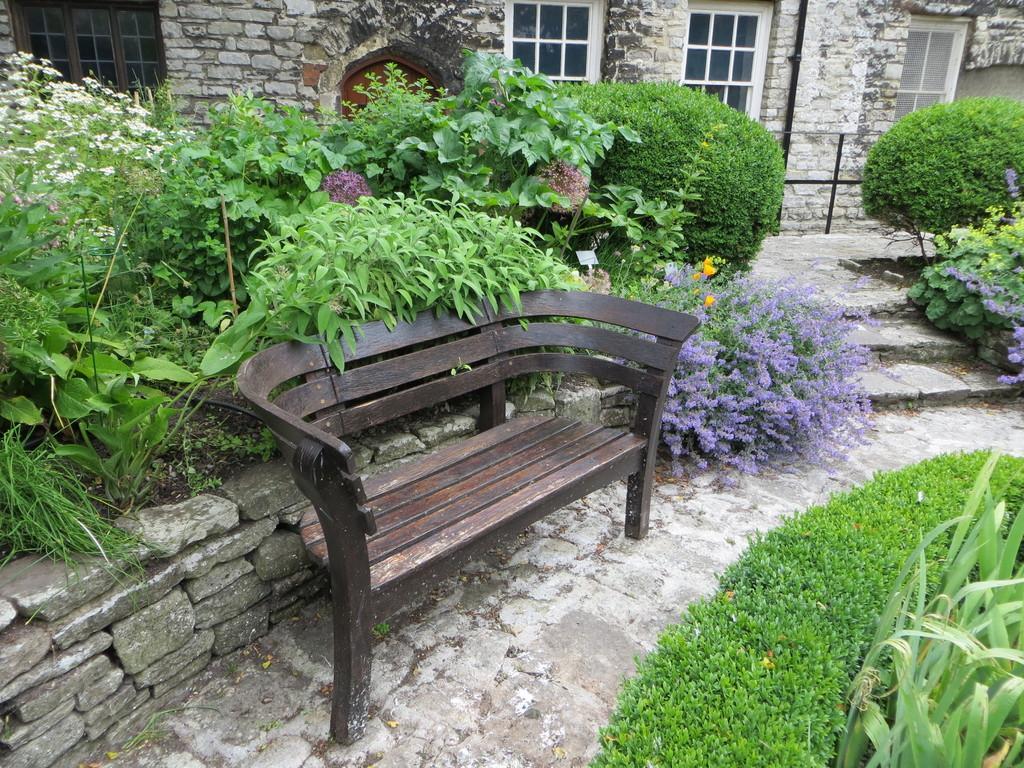Describe this image in one or two sentences. In this image there is a bench here. On the ground there are plants. In the background there is a building. These are the stairs. 